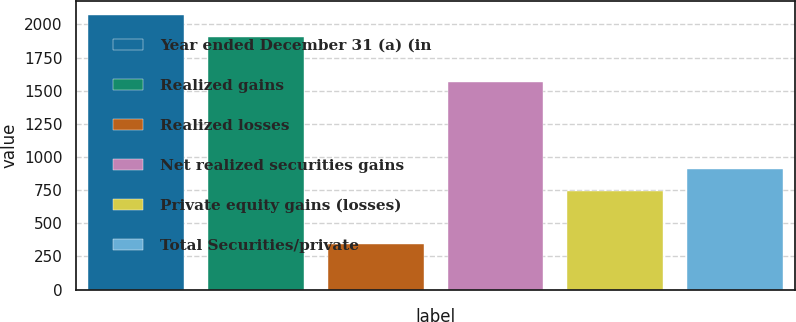Convert chart to OTSL. <chart><loc_0><loc_0><loc_500><loc_500><bar_chart><fcel>Year ended December 31 (a) (in<fcel>Realized gains<fcel>Realized losses<fcel>Net realized securities gains<fcel>Private equity gains (losses)<fcel>Total Securities/private<nl><fcel>2070.1<fcel>1904<fcel>341<fcel>1563<fcel>746<fcel>912.1<nl></chart> 